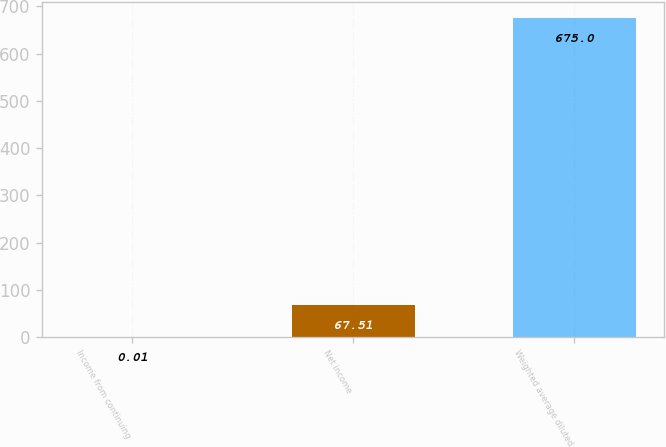Convert chart to OTSL. <chart><loc_0><loc_0><loc_500><loc_500><bar_chart><fcel>Income from continuing<fcel>Net income<fcel>Weighted average diluted<nl><fcel>0.01<fcel>67.51<fcel>675<nl></chart> 